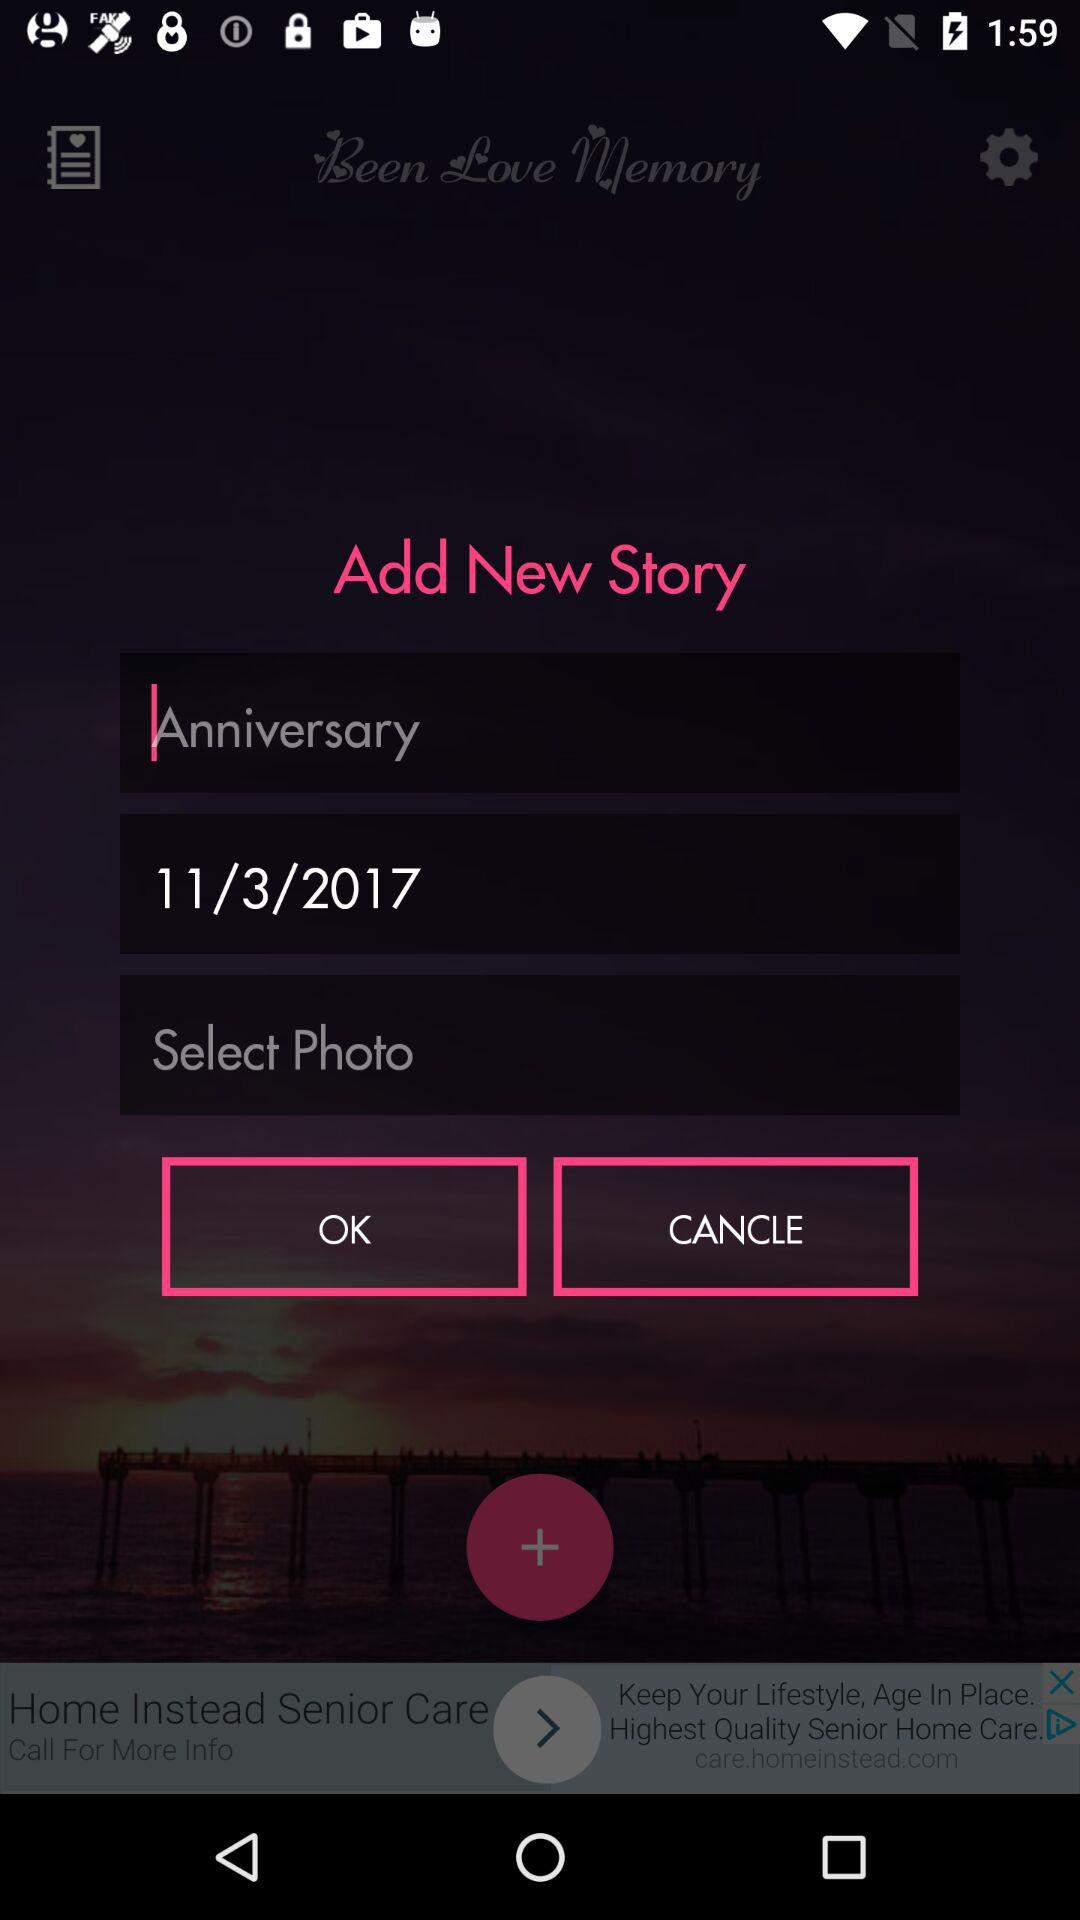What is the entered date? The entered date is November 3, 2017. 